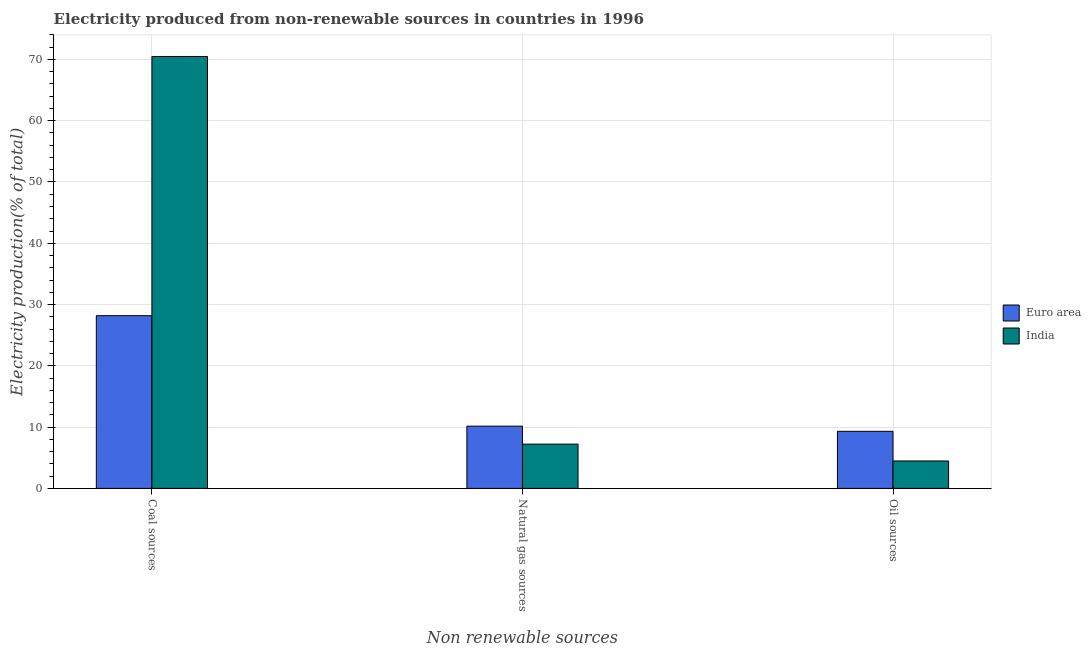Are the number of bars on each tick of the X-axis equal?
Ensure brevity in your answer.  Yes. How many bars are there on the 1st tick from the right?
Make the answer very short. 2. What is the label of the 1st group of bars from the left?
Your answer should be compact. Coal sources. What is the percentage of electricity produced by coal in Euro area?
Your response must be concise. 28.18. Across all countries, what is the maximum percentage of electricity produced by oil sources?
Give a very brief answer. 9.32. Across all countries, what is the minimum percentage of electricity produced by coal?
Ensure brevity in your answer.  28.18. In which country was the percentage of electricity produced by natural gas minimum?
Your answer should be very brief. India. What is the total percentage of electricity produced by oil sources in the graph?
Your answer should be compact. 13.8. What is the difference between the percentage of electricity produced by coal in India and that in Euro area?
Offer a very short reply. 42.29. What is the difference between the percentage of electricity produced by oil sources in India and the percentage of electricity produced by coal in Euro area?
Make the answer very short. -23.7. What is the average percentage of electricity produced by oil sources per country?
Ensure brevity in your answer.  6.9. What is the difference between the percentage of electricity produced by coal and percentage of electricity produced by natural gas in Euro area?
Provide a succinct answer. 18.02. In how many countries, is the percentage of electricity produced by coal greater than 26 %?
Provide a short and direct response. 2. What is the ratio of the percentage of electricity produced by coal in Euro area to that in India?
Provide a succinct answer. 0.4. Is the percentage of electricity produced by natural gas in India less than that in Euro area?
Offer a terse response. Yes. Is the difference between the percentage of electricity produced by natural gas in India and Euro area greater than the difference between the percentage of electricity produced by coal in India and Euro area?
Provide a succinct answer. No. What is the difference between the highest and the second highest percentage of electricity produced by oil sources?
Your answer should be compact. 4.84. What is the difference between the highest and the lowest percentage of electricity produced by oil sources?
Ensure brevity in your answer.  4.84. Is the sum of the percentage of electricity produced by oil sources in India and Euro area greater than the maximum percentage of electricity produced by coal across all countries?
Offer a terse response. No. What does the 2nd bar from the left in Coal sources represents?
Provide a short and direct response. India. What does the 1st bar from the right in Natural gas sources represents?
Offer a very short reply. India. How many bars are there?
Your answer should be very brief. 6. Are all the bars in the graph horizontal?
Keep it short and to the point. No. Are the values on the major ticks of Y-axis written in scientific E-notation?
Keep it short and to the point. No. How many legend labels are there?
Your response must be concise. 2. How are the legend labels stacked?
Make the answer very short. Vertical. What is the title of the graph?
Make the answer very short. Electricity produced from non-renewable sources in countries in 1996. Does "Yemen, Rep." appear as one of the legend labels in the graph?
Your response must be concise. No. What is the label or title of the X-axis?
Provide a short and direct response. Non renewable sources. What is the Electricity production(% of total) of Euro area in Coal sources?
Give a very brief answer. 28.18. What is the Electricity production(% of total) in India in Coal sources?
Offer a terse response. 70.48. What is the Electricity production(% of total) of Euro area in Natural gas sources?
Keep it short and to the point. 10.16. What is the Electricity production(% of total) in India in Natural gas sources?
Offer a very short reply. 7.23. What is the Electricity production(% of total) in Euro area in Oil sources?
Ensure brevity in your answer.  9.32. What is the Electricity production(% of total) in India in Oil sources?
Provide a succinct answer. 4.48. Across all Non renewable sources, what is the maximum Electricity production(% of total) in Euro area?
Offer a very short reply. 28.18. Across all Non renewable sources, what is the maximum Electricity production(% of total) in India?
Keep it short and to the point. 70.48. Across all Non renewable sources, what is the minimum Electricity production(% of total) of Euro area?
Your response must be concise. 9.32. Across all Non renewable sources, what is the minimum Electricity production(% of total) in India?
Your answer should be very brief. 4.48. What is the total Electricity production(% of total) in Euro area in the graph?
Provide a short and direct response. 47.66. What is the total Electricity production(% of total) in India in the graph?
Your answer should be very brief. 82.19. What is the difference between the Electricity production(% of total) of Euro area in Coal sources and that in Natural gas sources?
Your answer should be very brief. 18.02. What is the difference between the Electricity production(% of total) of India in Coal sources and that in Natural gas sources?
Your answer should be compact. 63.25. What is the difference between the Electricity production(% of total) of Euro area in Coal sources and that in Oil sources?
Ensure brevity in your answer.  18.86. What is the difference between the Electricity production(% of total) in India in Coal sources and that in Oil sources?
Make the answer very short. 66. What is the difference between the Electricity production(% of total) of Euro area in Natural gas sources and that in Oil sources?
Offer a terse response. 0.84. What is the difference between the Electricity production(% of total) of India in Natural gas sources and that in Oil sources?
Offer a very short reply. 2.75. What is the difference between the Electricity production(% of total) in Euro area in Coal sources and the Electricity production(% of total) in India in Natural gas sources?
Keep it short and to the point. 20.95. What is the difference between the Electricity production(% of total) of Euro area in Coal sources and the Electricity production(% of total) of India in Oil sources?
Make the answer very short. 23.7. What is the difference between the Electricity production(% of total) in Euro area in Natural gas sources and the Electricity production(% of total) in India in Oil sources?
Your response must be concise. 5.68. What is the average Electricity production(% of total) of Euro area per Non renewable sources?
Offer a terse response. 15.89. What is the average Electricity production(% of total) of India per Non renewable sources?
Keep it short and to the point. 27.4. What is the difference between the Electricity production(% of total) in Euro area and Electricity production(% of total) in India in Coal sources?
Provide a succinct answer. -42.29. What is the difference between the Electricity production(% of total) in Euro area and Electricity production(% of total) in India in Natural gas sources?
Make the answer very short. 2.93. What is the difference between the Electricity production(% of total) in Euro area and Electricity production(% of total) in India in Oil sources?
Your response must be concise. 4.84. What is the ratio of the Electricity production(% of total) of Euro area in Coal sources to that in Natural gas sources?
Offer a very short reply. 2.77. What is the ratio of the Electricity production(% of total) in India in Coal sources to that in Natural gas sources?
Ensure brevity in your answer.  9.75. What is the ratio of the Electricity production(% of total) of Euro area in Coal sources to that in Oil sources?
Ensure brevity in your answer.  3.02. What is the ratio of the Electricity production(% of total) of India in Coal sources to that in Oil sources?
Provide a succinct answer. 15.73. What is the ratio of the Electricity production(% of total) in Euro area in Natural gas sources to that in Oil sources?
Offer a terse response. 1.09. What is the ratio of the Electricity production(% of total) in India in Natural gas sources to that in Oil sources?
Make the answer very short. 1.61. What is the difference between the highest and the second highest Electricity production(% of total) of Euro area?
Offer a very short reply. 18.02. What is the difference between the highest and the second highest Electricity production(% of total) in India?
Ensure brevity in your answer.  63.25. What is the difference between the highest and the lowest Electricity production(% of total) of Euro area?
Give a very brief answer. 18.86. What is the difference between the highest and the lowest Electricity production(% of total) of India?
Provide a short and direct response. 66. 